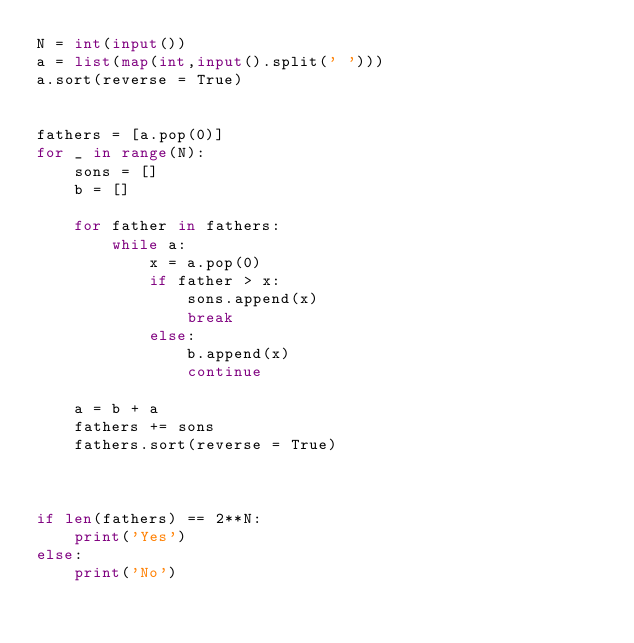<code> <loc_0><loc_0><loc_500><loc_500><_Python_>N = int(input())
a = list(map(int,input().split(' ')))
a.sort(reverse = True)
 
 
fathers = [a.pop(0)]
for _ in range(N):
    sons = []
    b = []

    for father in fathers:
        while a:
            x = a.pop(0)
            if father > x:
                sons.append(x)
                break
            else:
                b.append(x)
                continue
                
    a = b + a
    fathers += sons
    fathers.sort(reverse = True)
    


if len(fathers) == 2**N:
    print('Yes')
else:
    print('No')
</code> 